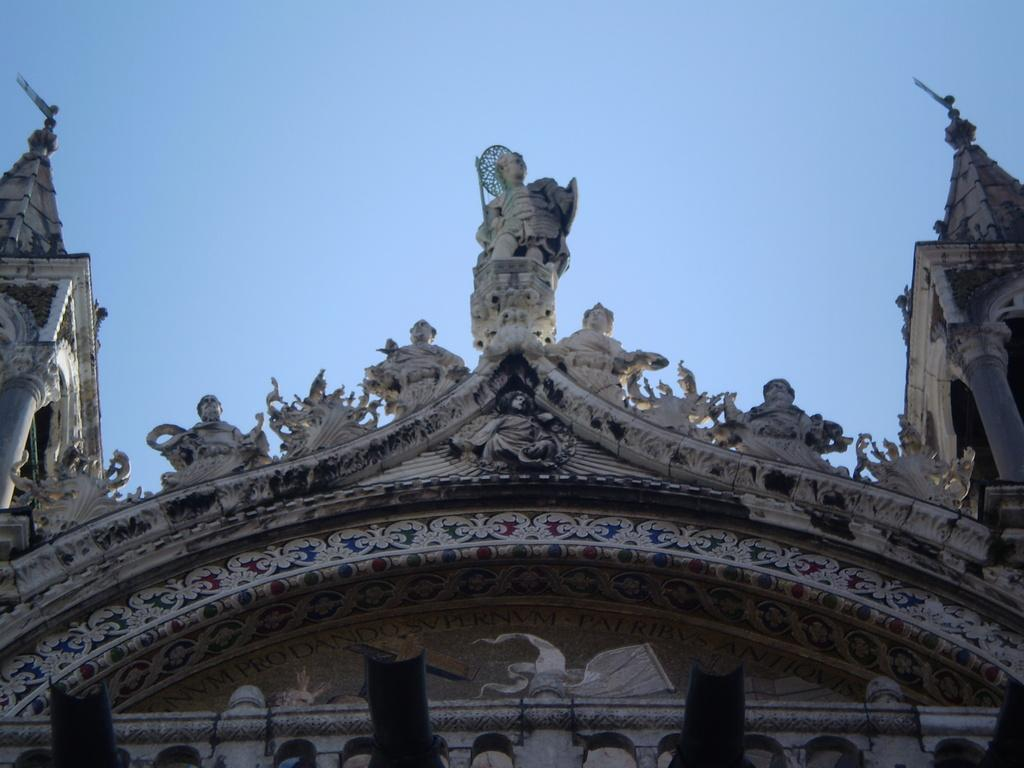What famous landmark is depicted in the image? St. Mark's Basilica is in the image. What type of beast can be seen lurking near St. Mark's Basilica in the image? There is no beast present near St. Mark's Basilica in the image. 